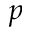<formula> <loc_0><loc_0><loc_500><loc_500>p</formula> 